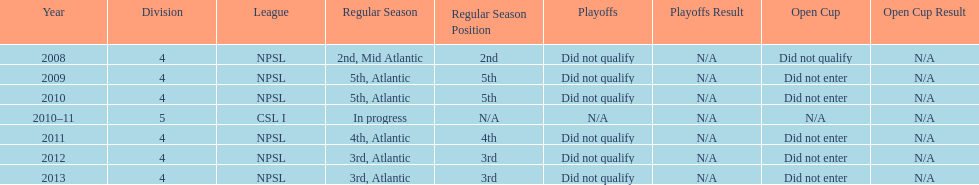Using the data, what should be the next year they will play? 2014. 